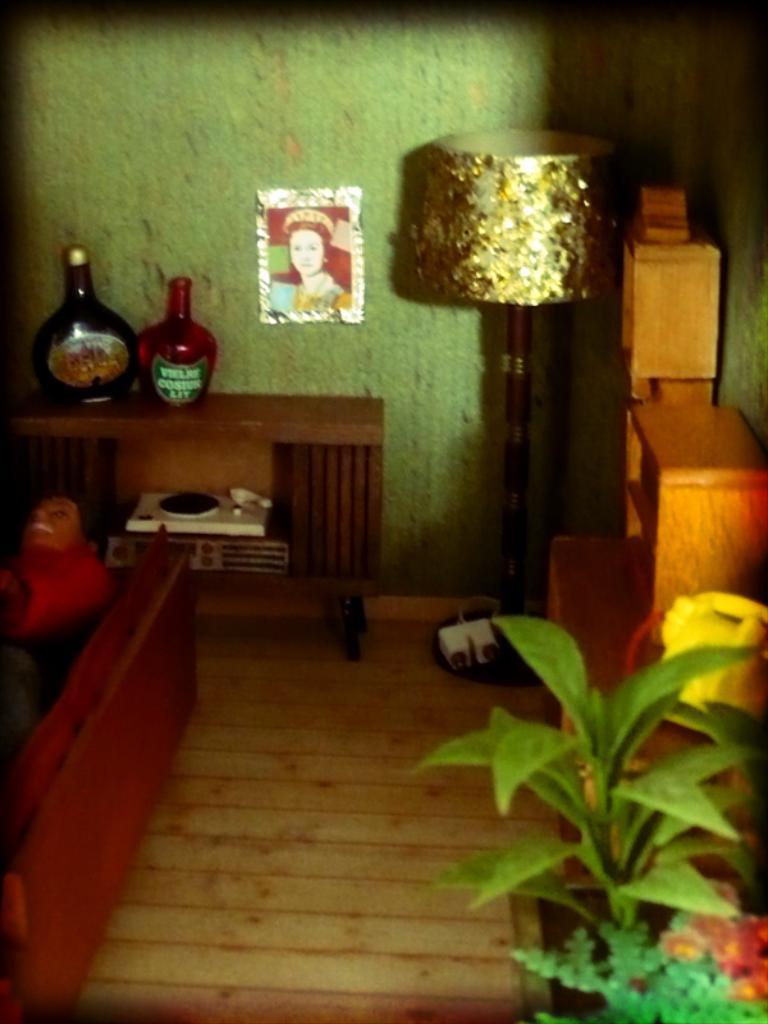Please provide a concise description of this image. On the left bottom of this picture, we see a man lying on the floor. Behind him, we see table on which two bottles are placed. On the right bottom of this picture, we see plant. Behind that we see a table or a cupboard. On background, we see a lamp and beside the lamp we see photo frame which is on the wall. 